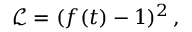<formula> <loc_0><loc_0><loc_500><loc_500>{ \mathcal { L } } = ( f ( t ) - 1 ) ^ { 2 } \, ,</formula> 